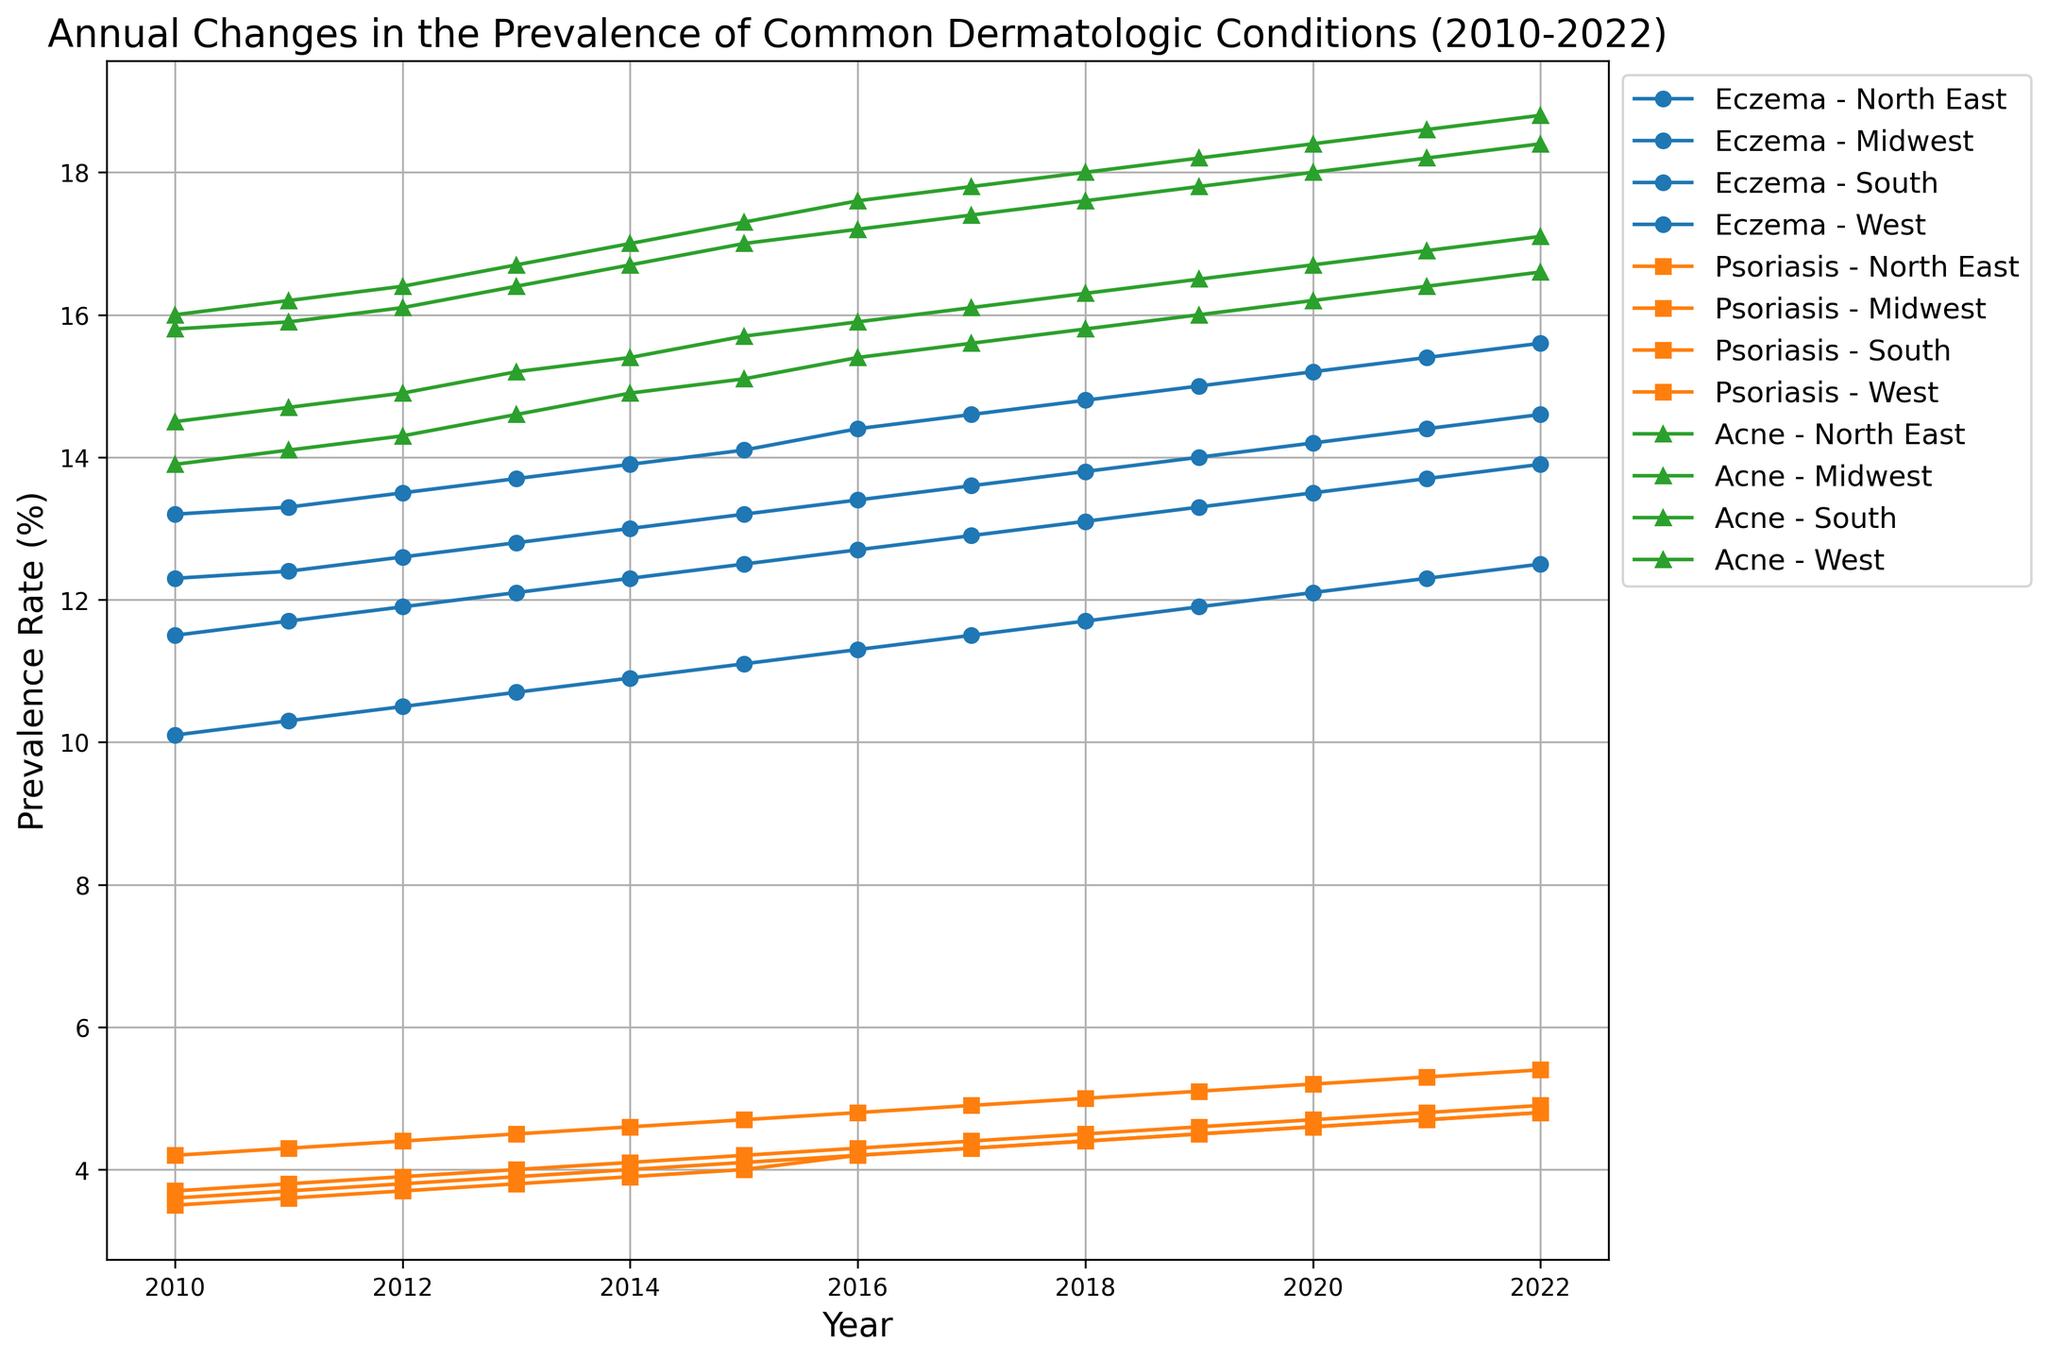What trend do we observe for the prevalence of eczema in the North East from 2010 to 2022? To identify the trend, look at the prevalence rates of eczema in the North East region for each year from 2010 to 2022. The plot shows an upward trend, starting at 12.3% in 2010 and ending at 14.6% in 2022 with some minor fluctuations.
Answer: Upward trend Which region had the highest prevalence of acne in 2022? To find the region with the highest prevalence of acne in 2022, compare the acne prevalence rates for each region in that year. The West had the highest prevalence rate at 18.8%.
Answer: West Did the prevalence rate of psoriasis in the Midwest show a consistent increase, decrease, or fluctuation from 2010 to 2022? By examining the prevalence rates for psoriasis in the Midwest over the given years, it becomes clear that the rate shows a consistent increase from 4.2% in 2010 to 5.4% in 2022.
Answer: Consistent increase Which condition had a more significant increase in prevalence in the South between 2010 and 2022, eczema or acne? To determine which condition had a more significant increase, calculate the difference in prevalence rates between 2010 and 2022 for both conditions in the South. Eczema increased from 11.5% to 13.9% (a 2.4% increase), while acne increased from 14.5% to 17.1% (a 2.6% increase). Thus, acne had a more significant increase.
Answer: Acne In which year did the prevalence of eczema in the West first surpass 14%? Check the prevalence rates of eczema in the West for each year and identify the year it first goes beyond 14%. The plot shows that in 2015, the prevalence rate surpassed 14% for the first time, reaching 14.1%.
Answer: 2015 What is the average prevalence rate of psoriasis in the South across all the years? To find the average, sum the prevalence rates of psoriasis in the South from 2010 to 2022 and then divide by the total number of years (13). The sum is 3.7 + 3.8 + 3.9 + 4.0 + 4.1 + 4.2 + 4.3 + 4.4 + 4.5 + 4.6 + 4.7 + 4.8 + 4.9 = 55.9. The average is 55.9 / 13 = 4.3%.
Answer: 4.3% Compare the prevalence trend of acne and eczema in the West from 2010 to 2022. Which condition shows a steeper increase? To compare the trends, calculate the change in prevalence rate for both conditions from 2010 to 2022. Acne starts at 16.0% and ends at 18.8%, a 2.8% increase. Eczema starts at 13.2% and ends at 15.6%, a 2.4% increase. Therefore, acne shows a steeper increase.
Answer: Acne 